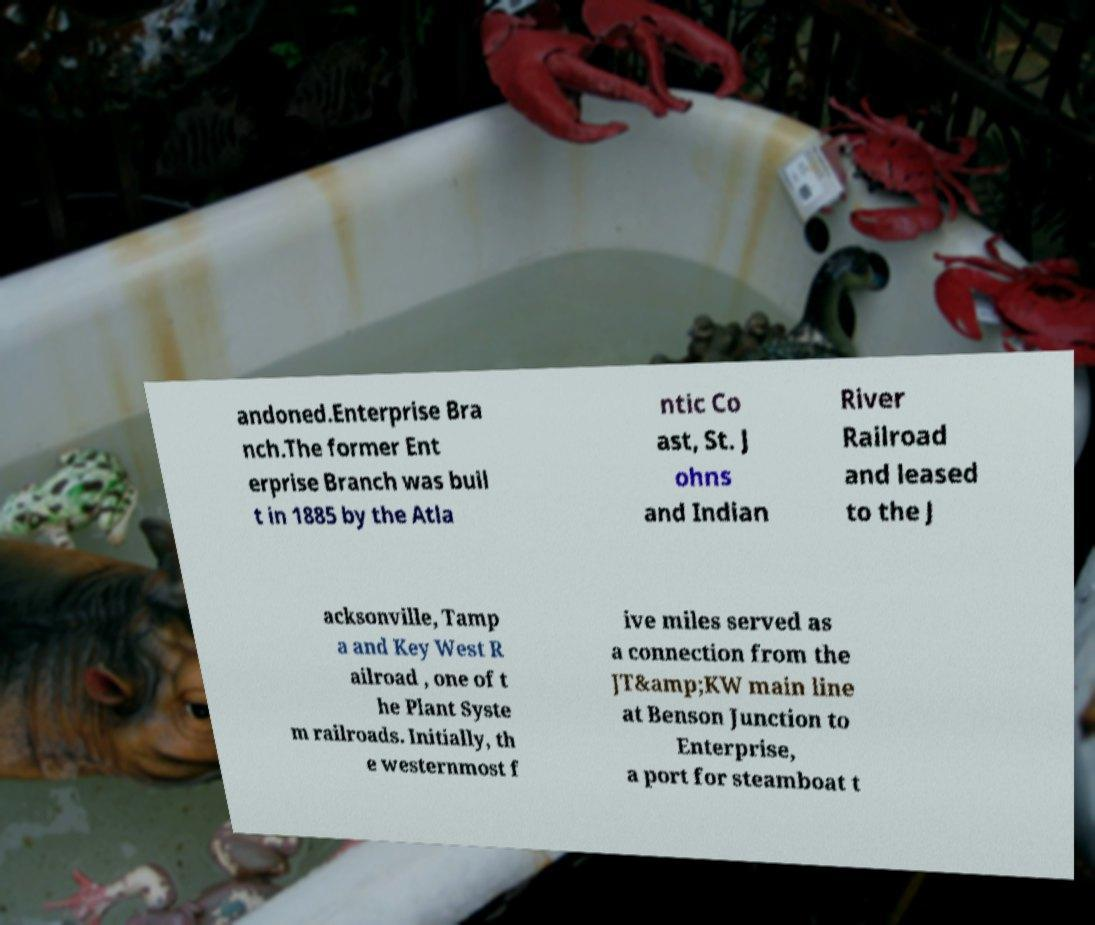What messages or text are displayed in this image? I need them in a readable, typed format. andoned.Enterprise Bra nch.The former Ent erprise Branch was buil t in 1885 by the Atla ntic Co ast, St. J ohns and Indian River Railroad and leased to the J acksonville, Tamp a and Key West R ailroad , one of t he Plant Syste m railroads. Initially, th e westernmost f ive miles served as a connection from the JT&amp;KW main line at Benson Junction to Enterprise, a port for steamboat t 